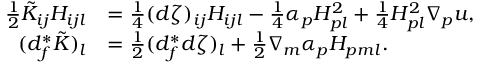<formula> <loc_0><loc_0><loc_500><loc_500>\begin{array} { r l } { \frac { 1 } { 2 } \tilde { K } _ { i j } H _ { i j l } } & { = \frac { 1 } { 4 } ( d \zeta ) _ { i j } H _ { i j l } - \frac { 1 } { 4 } \alpha _ { p } H _ { p l } ^ { 2 } + \frac { 1 } { 4 } H _ { p l } ^ { 2 } \nabla _ { p } u , } \\ { ( d _ { f } ^ { * } \tilde { K } ) _ { l } } & { = \frac { 1 } { 2 } ( d _ { f } ^ { * } d \zeta ) _ { l } + \frac { 1 } { 2 } \nabla _ { m } \alpha _ { p } H _ { p m l } . } \end{array}</formula> 